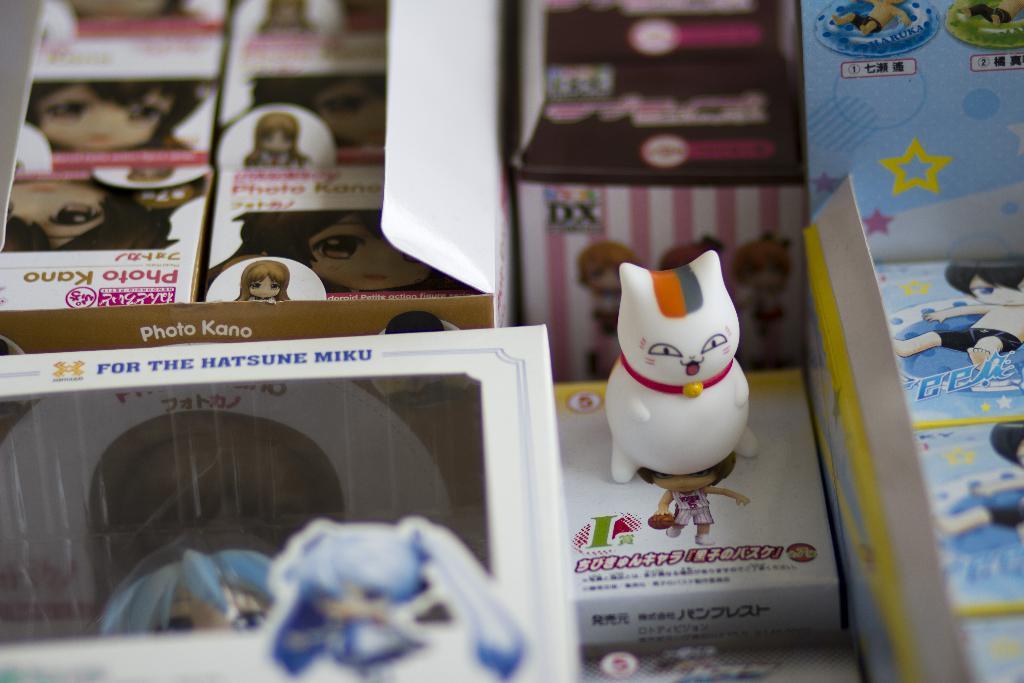What animal is being displayed?
Your answer should be very brief. Answering does not require reading text in the image. 